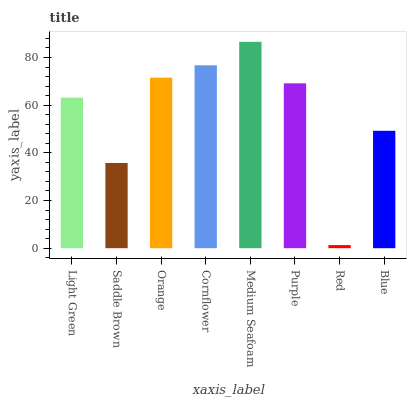Is Saddle Brown the minimum?
Answer yes or no. No. Is Saddle Brown the maximum?
Answer yes or no. No. Is Light Green greater than Saddle Brown?
Answer yes or no. Yes. Is Saddle Brown less than Light Green?
Answer yes or no. Yes. Is Saddle Brown greater than Light Green?
Answer yes or no. No. Is Light Green less than Saddle Brown?
Answer yes or no. No. Is Purple the high median?
Answer yes or no. Yes. Is Light Green the low median?
Answer yes or no. Yes. Is Light Green the high median?
Answer yes or no. No. Is Red the low median?
Answer yes or no. No. 